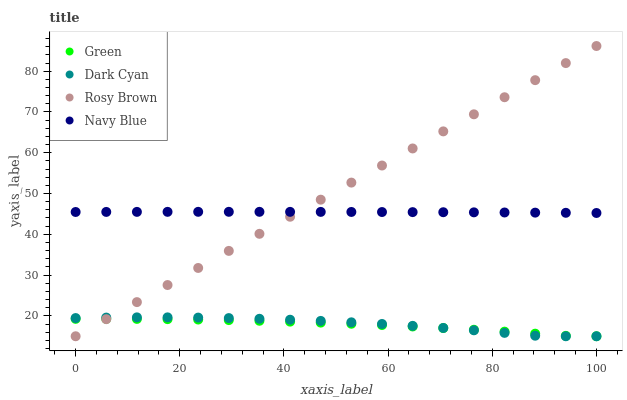Does Green have the minimum area under the curve?
Answer yes or no. Yes. Does Rosy Brown have the maximum area under the curve?
Answer yes or no. Yes. Does Navy Blue have the minimum area under the curve?
Answer yes or no. No. Does Navy Blue have the maximum area under the curve?
Answer yes or no. No. Is Rosy Brown the smoothest?
Answer yes or no. Yes. Is Dark Cyan the roughest?
Answer yes or no. Yes. Is Navy Blue the smoothest?
Answer yes or no. No. Is Navy Blue the roughest?
Answer yes or no. No. Does Dark Cyan have the lowest value?
Answer yes or no. Yes. Does Navy Blue have the lowest value?
Answer yes or no. No. Does Rosy Brown have the highest value?
Answer yes or no. Yes. Does Navy Blue have the highest value?
Answer yes or no. No. Is Dark Cyan less than Navy Blue?
Answer yes or no. Yes. Is Navy Blue greater than Green?
Answer yes or no. Yes. Does Rosy Brown intersect Dark Cyan?
Answer yes or no. Yes. Is Rosy Brown less than Dark Cyan?
Answer yes or no. No. Is Rosy Brown greater than Dark Cyan?
Answer yes or no. No. Does Dark Cyan intersect Navy Blue?
Answer yes or no. No. 